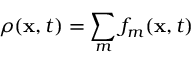Convert formula to latex. <formula><loc_0><loc_0><loc_500><loc_500>\rho ( { x } , t ) = \sum _ { m } f _ { m } ( { x } , t )</formula> 